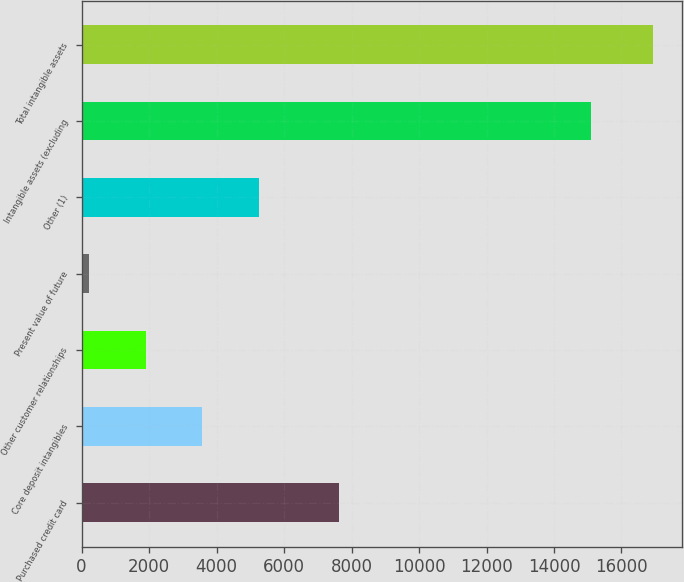Convert chart to OTSL. <chart><loc_0><loc_0><loc_500><loc_500><bar_chart><fcel>Purchased credit card<fcel>Core deposit intangibles<fcel>Other customer relationships<fcel>Present value of future<fcel>Other (1)<fcel>Intangible assets (excluding<fcel>Total intangible assets<nl><fcel>7626<fcel>3575<fcel>1904<fcel>233<fcel>5246<fcel>15098<fcel>16943<nl></chart> 